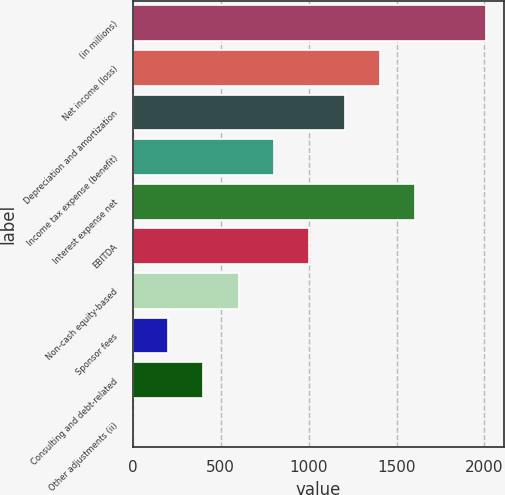Convert chart to OTSL. <chart><loc_0><loc_0><loc_500><loc_500><bar_chart><fcel>(in millions)<fcel>Net income (loss)<fcel>Depreciation and amortization<fcel>Income tax expense (benefit)<fcel>Interest expense net<fcel>EBITDA<fcel>Non-cash equity-based<fcel>Sponsor fees<fcel>Consulting and debt-related<fcel>Other adjustments (ii)<nl><fcel>2009<fcel>1406.33<fcel>1205.44<fcel>803.66<fcel>1607.22<fcel>1004.55<fcel>602.77<fcel>200.99<fcel>401.88<fcel>0.1<nl></chart> 